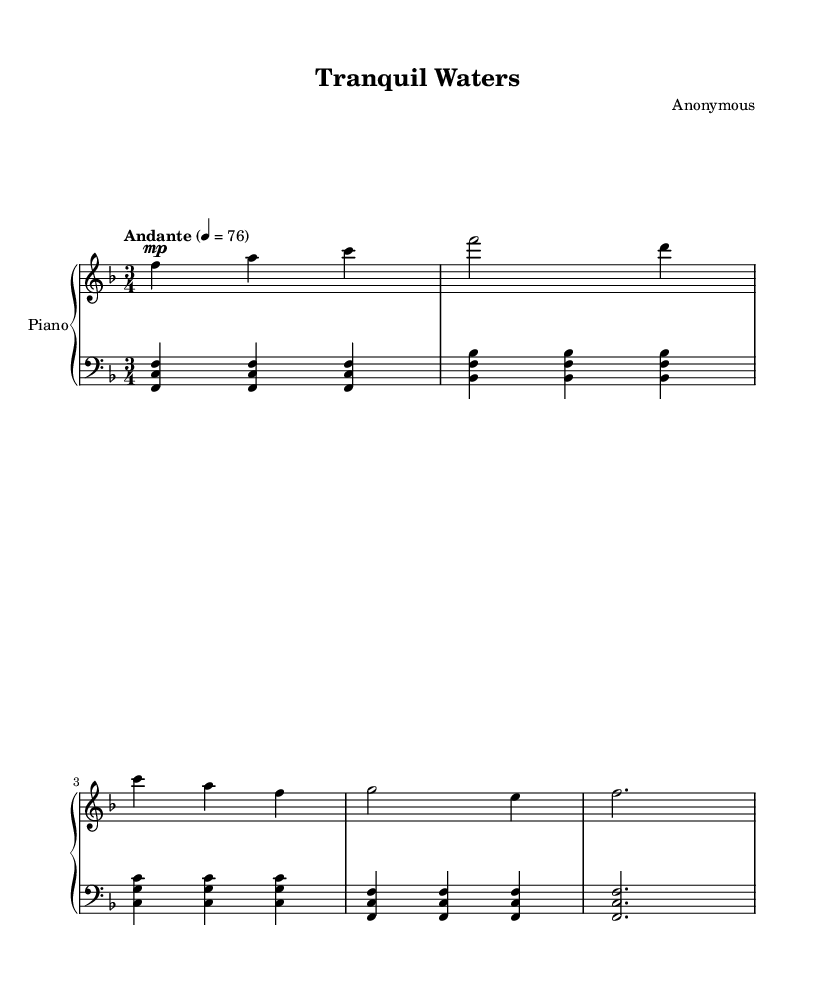What is the key signature of this music? The key signature indicated at the beginning of the sheet music shows one flat, which corresponds to F major.
Answer: F major What is the time signature of this piece? The time signature is found right after the key signature, showing three beats per measure, which is represented as 3/4.
Answer: 3/4 What is the tempo marking for this piece? The tempo marking is written at the beginning of the score, indicating "Andante" with a specific metronome marking of 76 beats per minute.
Answer: Andante, 76 What is the dynamic marking for the right hand at the beginning? The dynamic marking indicated at the start of the right hand part is "mp," which stands for mezzo-piano, meaning moderately soft.
Answer: mp How many measures are in the entire score? By counting the measures in both the right and left hand parts, we find there are a total of six measures in the music sheet.
Answer: 6 Which section of the score features a bass clef? The left hand part is specified to be in bass clef, which indicates lower notes typically played by the left hand.
Answer: left hand What kind of musical piece is "Tranquil Waters?" The title and calm tempo, as well as the overall character of the music, suggest that this piece is a soothing classical piano composition aimed at relaxation.
Answer: Soothing classical piano piece 